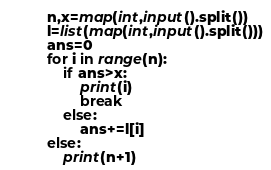Convert code to text. <code><loc_0><loc_0><loc_500><loc_500><_Python_>n,x=map(int,input().split())
l=list(map(int,input().split()))
ans=0
for i in range(n):
    if ans>x:
        print(i)
        break
    else:
        ans+=l[i]
else:
    print(n+1)
</code> 